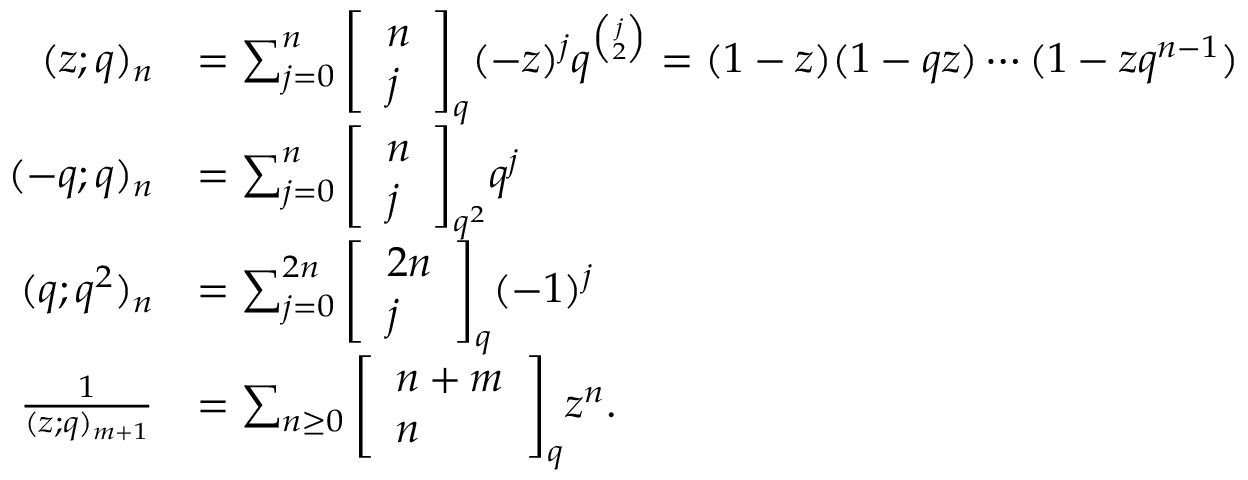<formula> <loc_0><loc_0><loc_500><loc_500>{ \begin{array} { r l } { ( z ; q ) _ { n } } & { = \sum _ { j = 0 } ^ { n } { \left [ \begin{array} { l } { n } \\ { j } \end{array} \right ] } _ { q } ( - z ) ^ { j } q ^ { \binom { j } { 2 } } = ( 1 - z ) ( 1 - q z ) \cdots ( 1 - z q ^ { n - 1 } ) } \\ { ( - q ; q ) _ { n } } & { = \sum _ { j = 0 } ^ { n } { \left [ \begin{array} { l } { n } \\ { j } \end{array} \right ] } _ { q ^ { 2 } } q ^ { j } } \\ { ( q ; q ^ { 2 } ) _ { n } } & { = \sum _ { j = 0 } ^ { 2 n } { \left [ \begin{array} { l } { 2 n } \\ { j } \end{array} \right ] } _ { q } ( - 1 ) ^ { j } } \\ { { \frac { 1 } { ( z ; q ) _ { m + 1 } } } } & { = \sum _ { n \geq 0 } { \left [ \begin{array} { l } { n + m } \\ { n } \end{array} \right ] } _ { q } z ^ { n } . } \end{array} }</formula> 